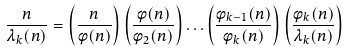Convert formula to latex. <formula><loc_0><loc_0><loc_500><loc_500>\frac { n } { \lambda _ { k } ( n ) } = \left ( \frac { n } { \phi ( n ) } \right ) \left ( \frac { \phi ( n ) } { \phi _ { 2 } ( n ) } \right ) \dots \left ( \frac { \phi _ { k - 1 } ( n ) } { \phi _ { k } ( n ) } \right ) \left ( \frac { \phi _ { k } ( n ) } { \lambda _ { k } ( n ) } \right )</formula> 